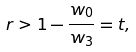<formula> <loc_0><loc_0><loc_500><loc_500>r > 1 - \frac { w _ { 0 } } { w _ { 3 } } = t ,</formula> 